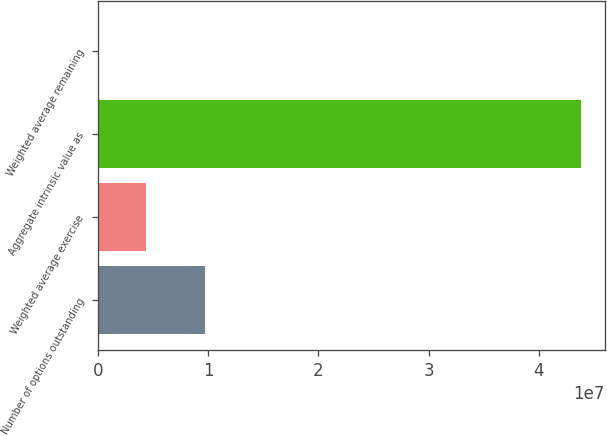<chart> <loc_0><loc_0><loc_500><loc_500><bar_chart><fcel>Number of options outstanding<fcel>Weighted average exercise<fcel>Aggregate intrinsic value as<fcel>Weighted average remaining<nl><fcel>9.67479e+06<fcel>4.38064e+06<fcel>4.38064e+07<fcel>2.6<nl></chart> 